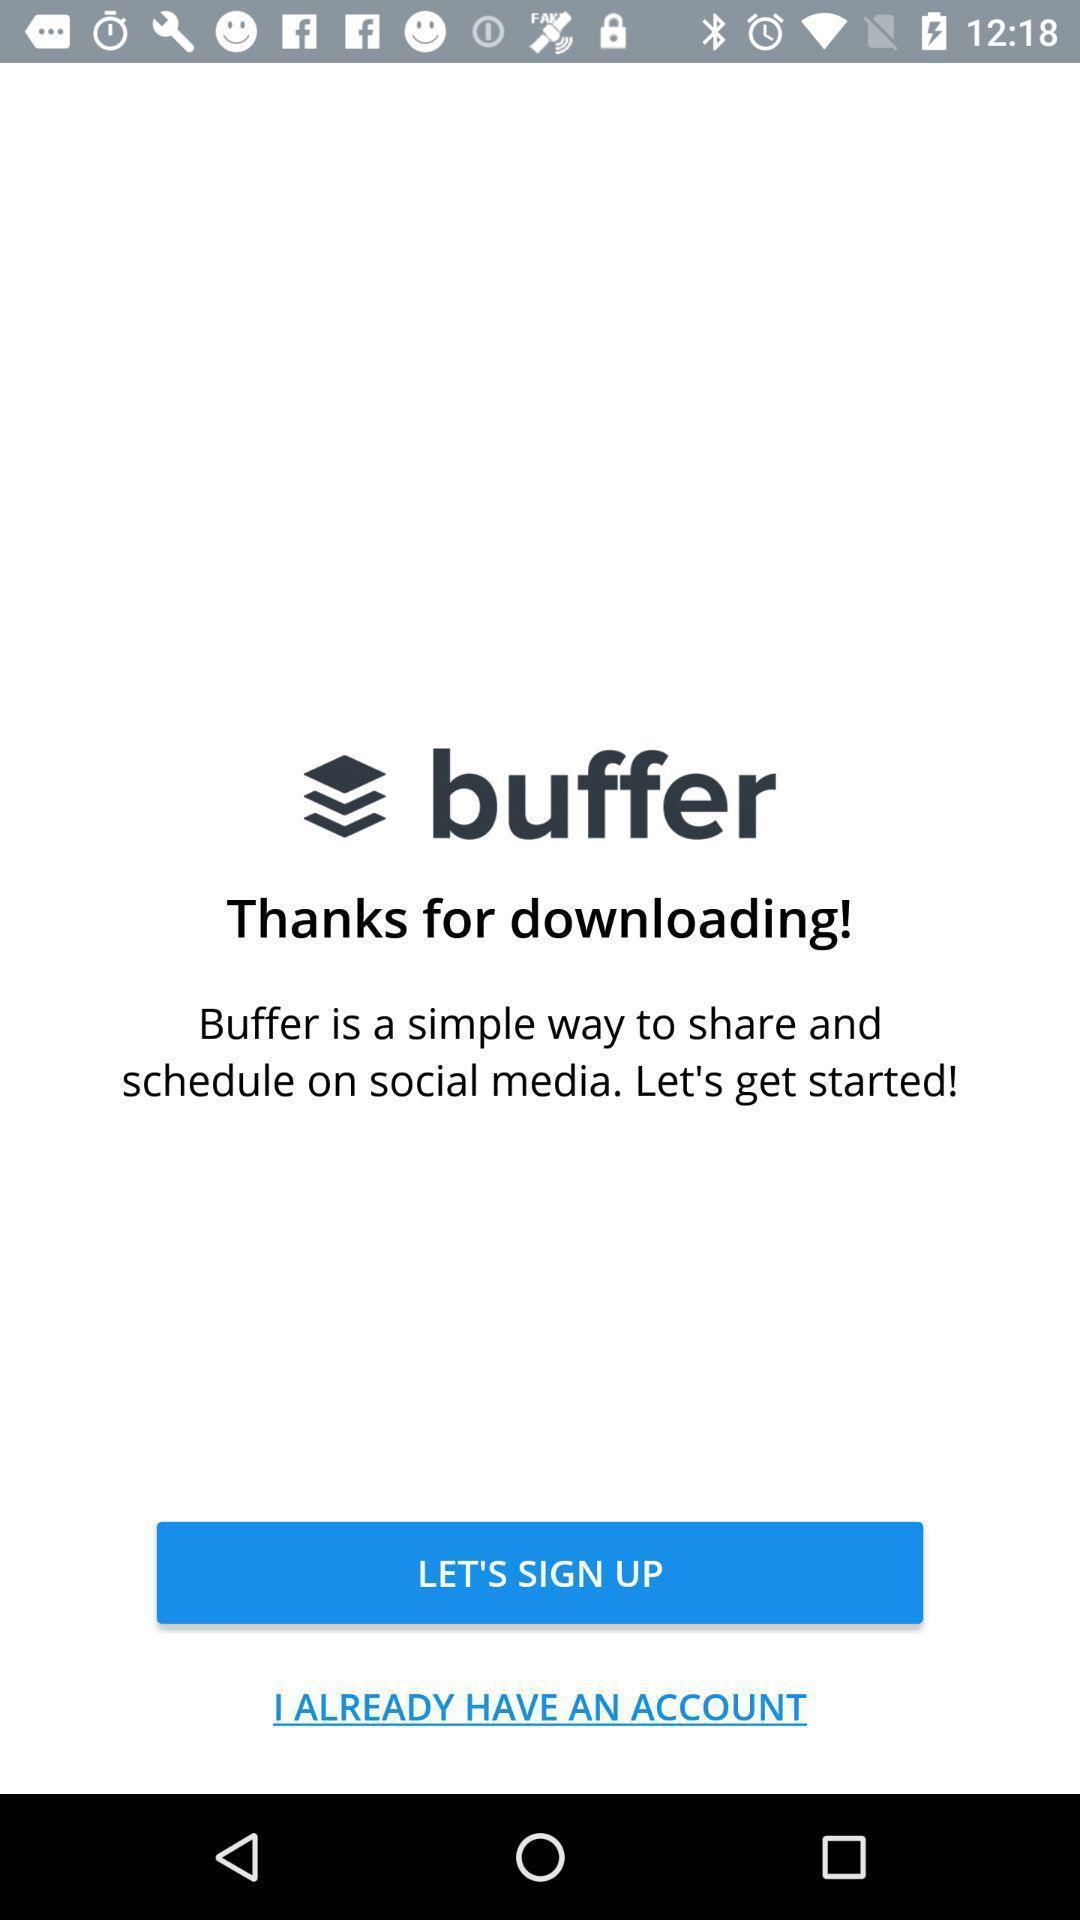Provide a detailed account of this screenshot. Signup page s. 